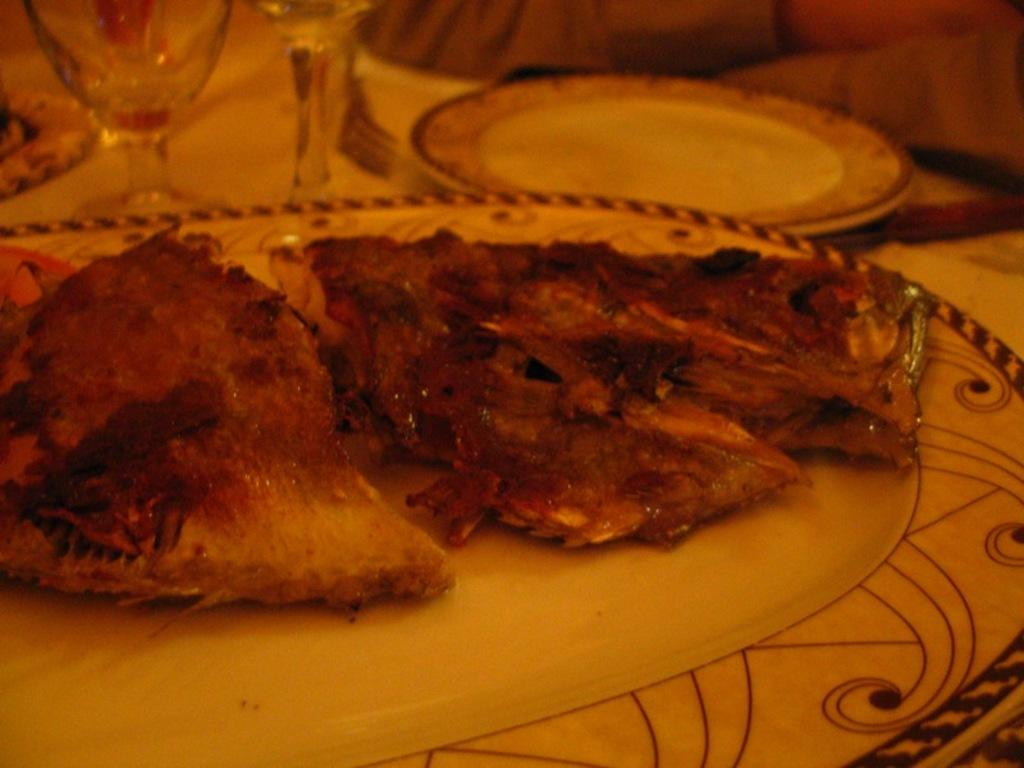What piece of furniture is present in the image? There is a table in the image. What items are placed on the table? There are plates, glasses, food, and other objects on the table. Can you describe the person's hands in the image? A person's hands are visible in the image. What type of objects can be seen on the table? There are plates, glasses, and other objects on the table. What type of steel is visible at the seashore in the image? There is no steel or seashore present in the image; it features a table with various items on it. How many planes are flying over the table in the image? There are no planes visible in the image; it only features a table with various items on it. 